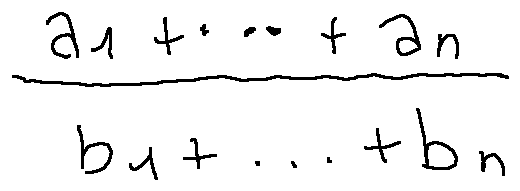Convert formula to latex. <formula><loc_0><loc_0><loc_500><loc_500>\frac { a _ { 1 } + \dots + a _ { n } } { b _ { 1 } + \dots + b _ { n } }</formula> 